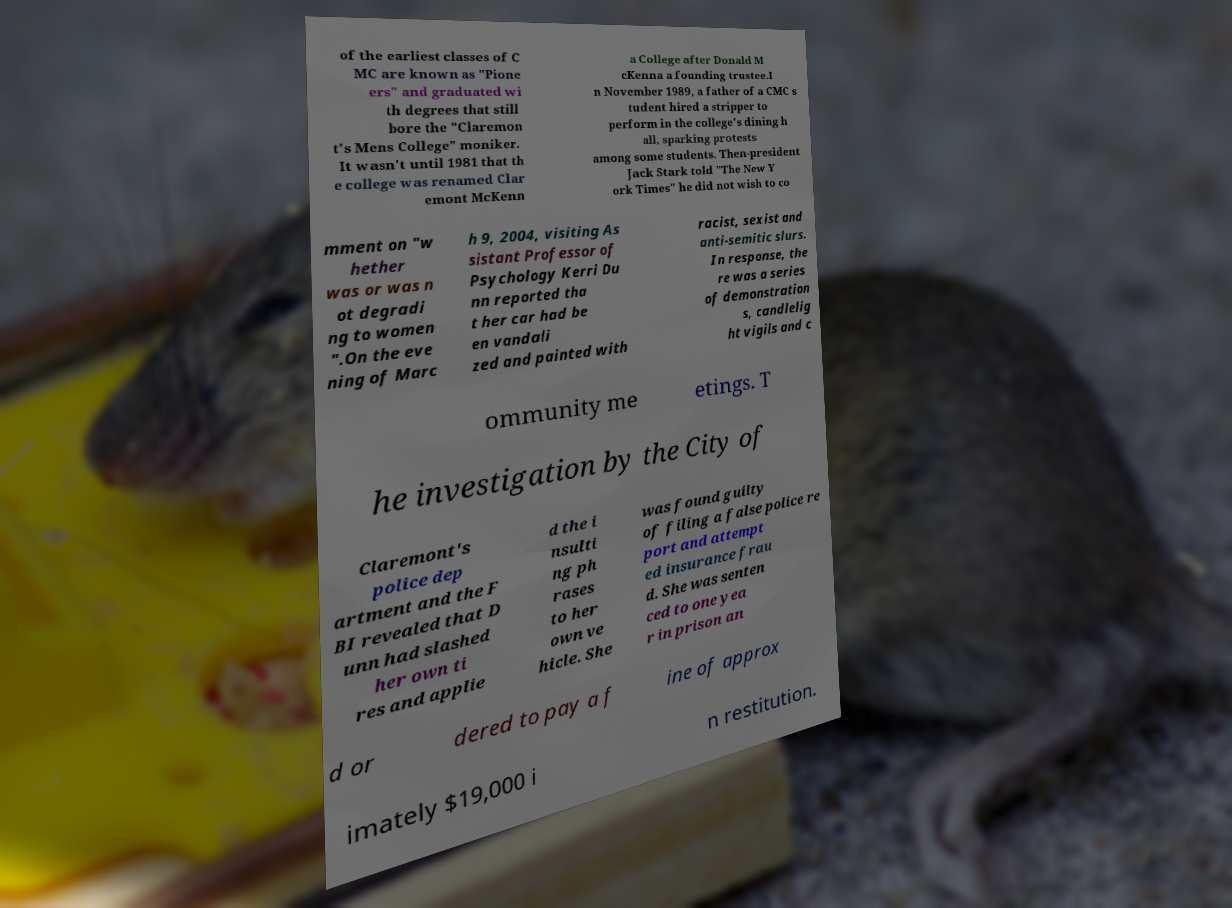There's text embedded in this image that I need extracted. Can you transcribe it verbatim? of the earliest classes of C MC are known as "Pione ers" and graduated wi th degrees that still bore the "Claremon t's Mens College" moniker. It wasn't until 1981 that th e college was renamed Clar emont McKenn a College after Donald M cKenna a founding trustee.I n November 1989, a father of a CMC s tudent hired a stripper to perform in the college's dining h all, sparking protests among some students. Then-president Jack Stark told "The New Y ork Times" he did not wish to co mment on "w hether was or was n ot degradi ng to women ".On the eve ning of Marc h 9, 2004, visiting As sistant Professor of Psychology Kerri Du nn reported tha t her car had be en vandali zed and painted with racist, sexist and anti-semitic slurs. In response, the re was a series of demonstration s, candlelig ht vigils and c ommunity me etings. T he investigation by the City of Claremont's police dep artment and the F BI revealed that D unn had slashed her own ti res and applie d the i nsulti ng ph rases to her own ve hicle. She was found guilty of filing a false police re port and attempt ed insurance frau d. She was senten ced to one yea r in prison an d or dered to pay a f ine of approx imately $19,000 i n restitution. 